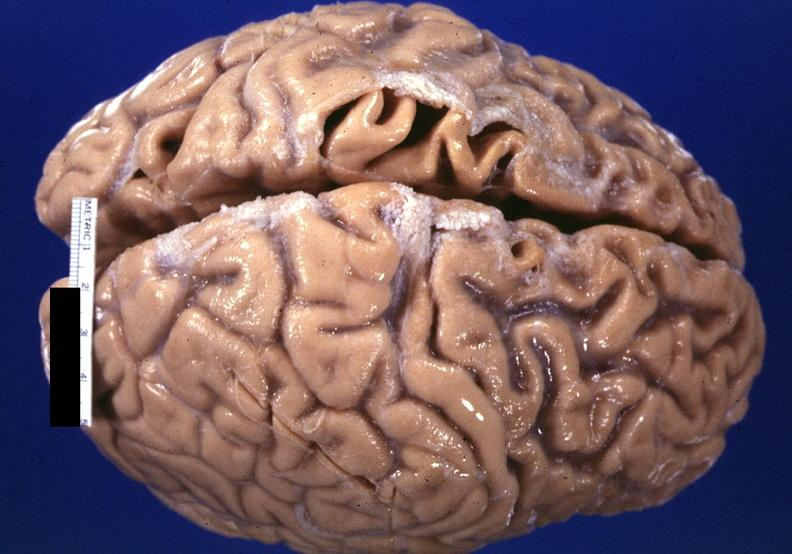s nervous present?
Answer the question using a single word or phrase. Yes 